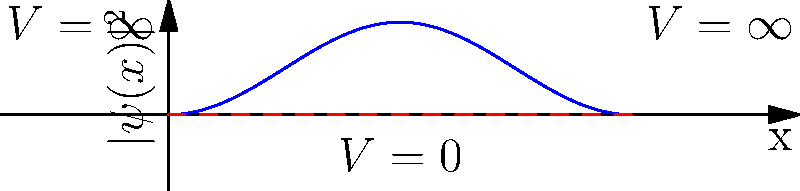As a software engineer with experience in complex systems, consider an electron confined in a one-dimensional infinite potential well of width $L = 5$ nm. The graph shows the probability density $|\psi(x)|^2$ for the electron's ground state. If we double the width of the well to $10$ nm, how would the number of nodes in the ground state wave function change? To answer this question, let's approach it step-by-step:

1. First, recall that for a particle in a box (infinite potential well), the wave function for the nth state is given by:

   $$\psi_n(x) = \sqrt{\frac{2}{L}} \sin(\frac{n\pi x}{L})$$

2. The number of nodes (points where the wave function equals zero) for the nth state is n-1.

3. In the ground state (n = 1), there are no nodes between the walls of the well, regardless of the well's width.

4. The graph shows the probability density $|\psi(x)|^2$ for the ground state, which has no nodes within the well.

5. Doubling the width of the well from 5 nm to 10 nm will change the wave function by stretching it horizontally, but it won't introduce any new nodes.

6. The ground state will still be described by half a sine wave, just over a larger distance.

7. Therefore, the number of nodes in the ground state wave function will remain the same: zero.

This concept is analogous to how increasing the size of a system in software engineering doesn't necessarily increase its fundamental complexity, but rather scales its existing properties.
Answer: No change (still zero nodes) 